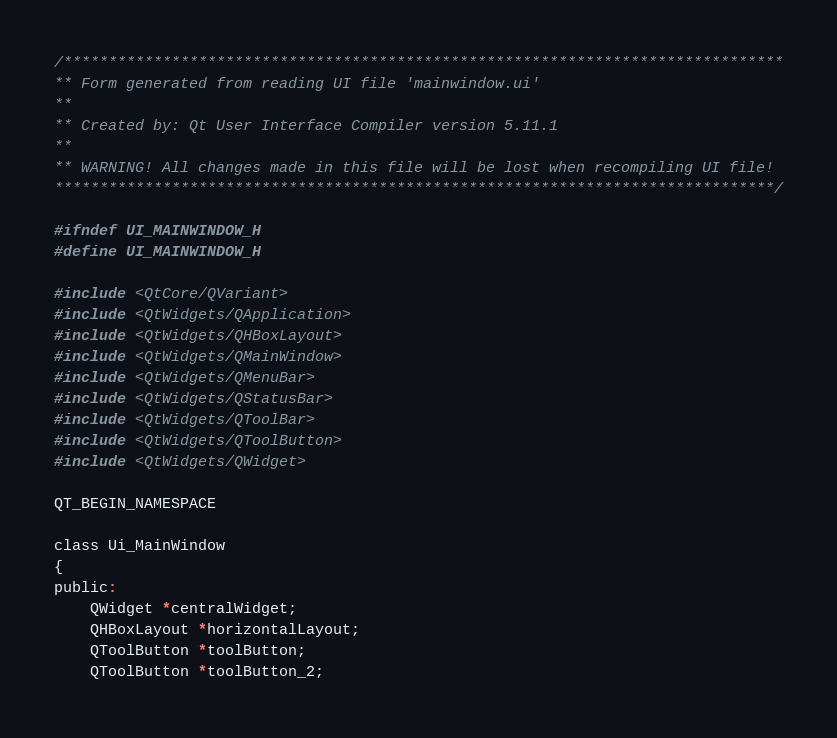Convert code to text. <code><loc_0><loc_0><loc_500><loc_500><_C_>/********************************************************************************
** Form generated from reading UI file 'mainwindow.ui'
**
** Created by: Qt User Interface Compiler version 5.11.1
**
** WARNING! All changes made in this file will be lost when recompiling UI file!
********************************************************************************/

#ifndef UI_MAINWINDOW_H
#define UI_MAINWINDOW_H

#include <QtCore/QVariant>
#include <QtWidgets/QApplication>
#include <QtWidgets/QHBoxLayout>
#include <QtWidgets/QMainWindow>
#include <QtWidgets/QMenuBar>
#include <QtWidgets/QStatusBar>
#include <QtWidgets/QToolBar>
#include <QtWidgets/QToolButton>
#include <QtWidgets/QWidget>

QT_BEGIN_NAMESPACE

class Ui_MainWindow
{
public:
    QWidget *centralWidget;
    QHBoxLayout *horizontalLayout;
    QToolButton *toolButton;
    QToolButton *toolButton_2;</code> 